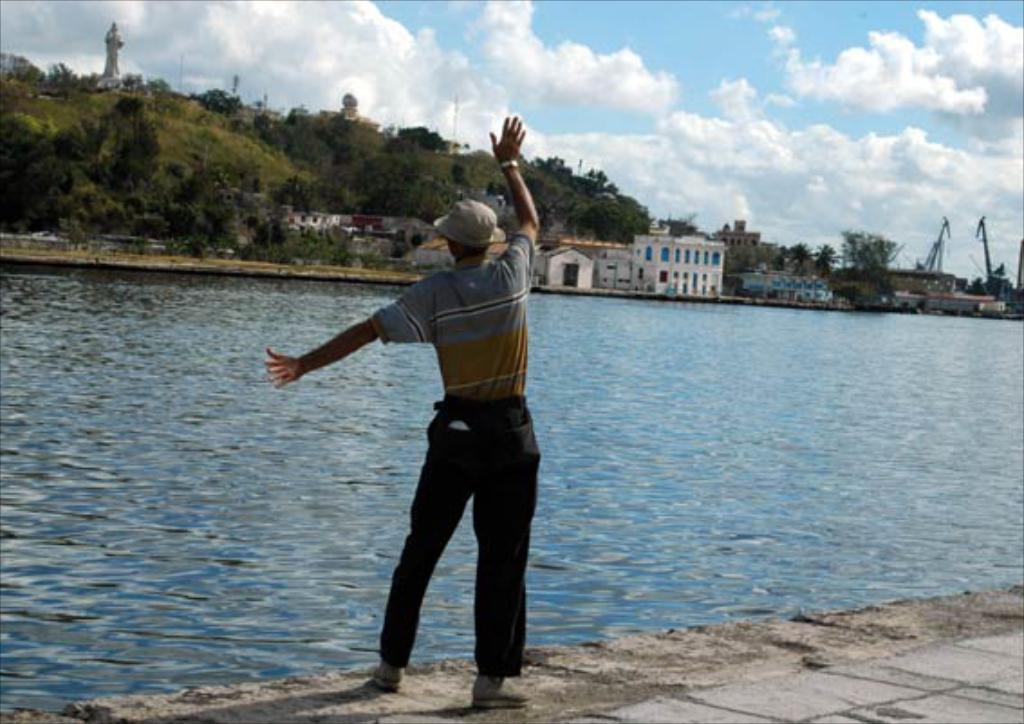What is the main subject in the image? There is a person standing in front of a water lake. What can be seen on the other side of the water? There are buildings and trees on the other side of the water. Where is the chain located in the image? There is no chain present in the image. What type of show can be seen taking place on the water? There is no show taking place on the water in the image. 